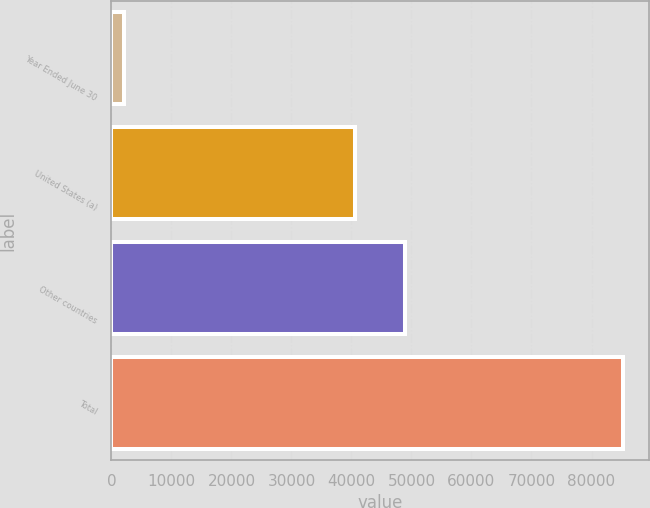Convert chart. <chart><loc_0><loc_0><loc_500><loc_500><bar_chart><fcel>Year Ended June 30<fcel>United States (a)<fcel>Other countries<fcel>Total<nl><fcel>2016<fcel>40578<fcel>48908.4<fcel>85320<nl></chart> 